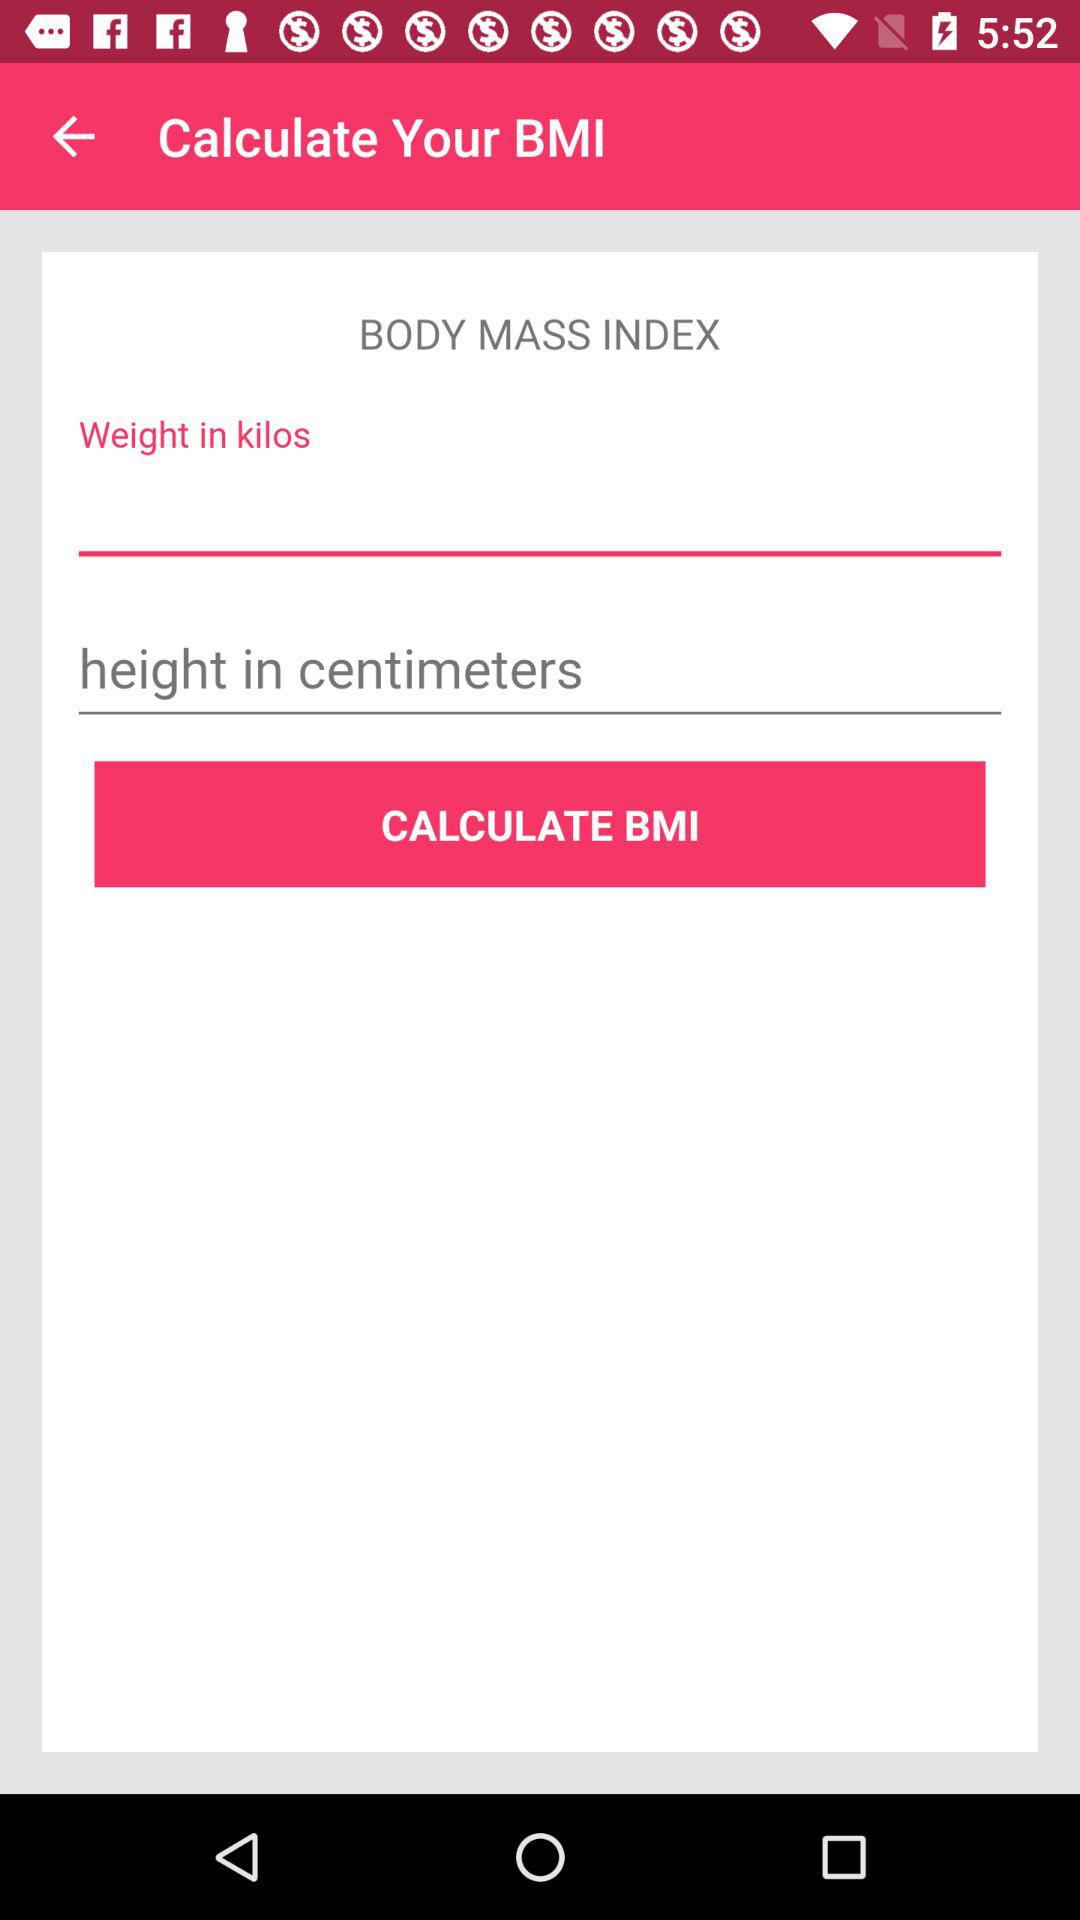What is the given unit of height? The given unit of height is centimeters. 